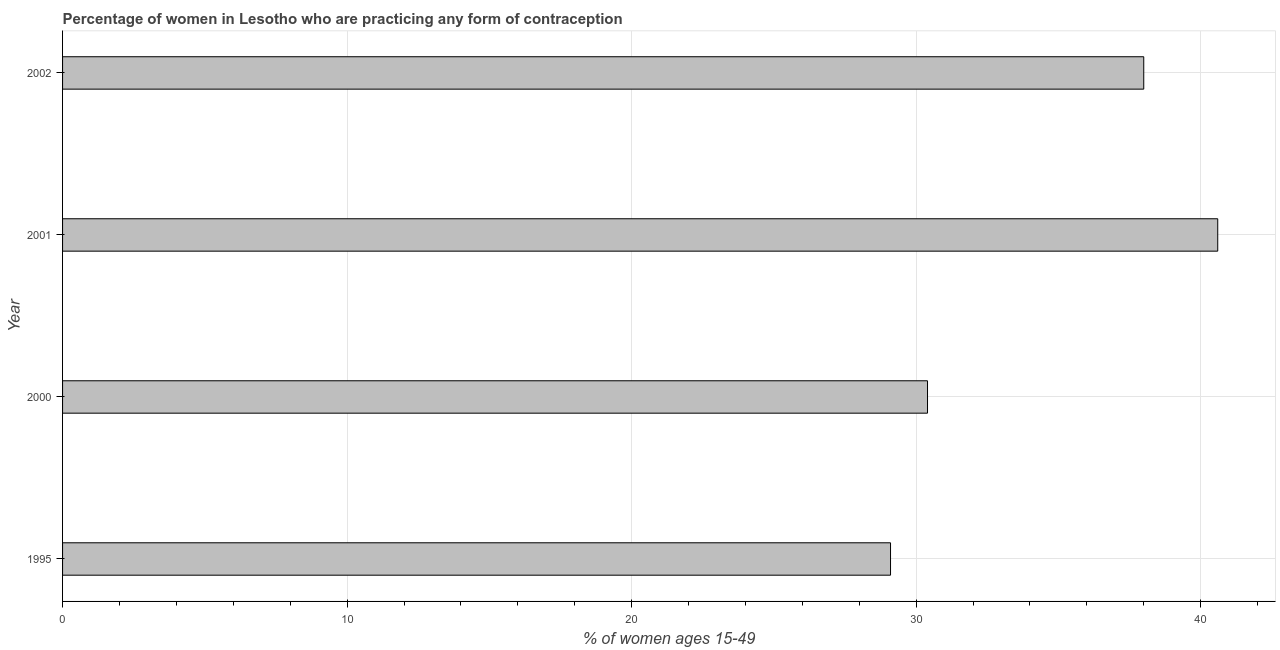Does the graph contain any zero values?
Provide a short and direct response. No. What is the title of the graph?
Provide a succinct answer. Percentage of women in Lesotho who are practicing any form of contraception. What is the label or title of the X-axis?
Offer a very short reply. % of women ages 15-49. What is the label or title of the Y-axis?
Your response must be concise. Year. What is the contraceptive prevalence in 1995?
Your answer should be very brief. 29.1. Across all years, what is the maximum contraceptive prevalence?
Your answer should be very brief. 40.6. Across all years, what is the minimum contraceptive prevalence?
Offer a very short reply. 29.1. In which year was the contraceptive prevalence maximum?
Keep it short and to the point. 2001. In which year was the contraceptive prevalence minimum?
Offer a terse response. 1995. What is the sum of the contraceptive prevalence?
Provide a succinct answer. 138.1. What is the average contraceptive prevalence per year?
Your response must be concise. 34.52. What is the median contraceptive prevalence?
Provide a succinct answer. 34.2. In how many years, is the contraceptive prevalence greater than 2 %?
Your answer should be very brief. 4. Is the difference between the contraceptive prevalence in 2000 and 2002 greater than the difference between any two years?
Provide a succinct answer. No. Is the sum of the contraceptive prevalence in 1995 and 2001 greater than the maximum contraceptive prevalence across all years?
Offer a very short reply. Yes. How many bars are there?
Keep it short and to the point. 4. What is the difference between two consecutive major ticks on the X-axis?
Provide a short and direct response. 10. Are the values on the major ticks of X-axis written in scientific E-notation?
Provide a short and direct response. No. What is the % of women ages 15-49 of 1995?
Make the answer very short. 29.1. What is the % of women ages 15-49 of 2000?
Your answer should be very brief. 30.4. What is the % of women ages 15-49 of 2001?
Provide a short and direct response. 40.6. What is the difference between the % of women ages 15-49 in 1995 and 2000?
Offer a terse response. -1.3. What is the difference between the % of women ages 15-49 in 1995 and 2001?
Provide a succinct answer. -11.5. What is the difference between the % of women ages 15-49 in 1995 and 2002?
Your answer should be compact. -8.9. What is the difference between the % of women ages 15-49 in 2000 and 2001?
Make the answer very short. -10.2. What is the difference between the % of women ages 15-49 in 2000 and 2002?
Provide a succinct answer. -7.6. What is the difference between the % of women ages 15-49 in 2001 and 2002?
Provide a succinct answer. 2.6. What is the ratio of the % of women ages 15-49 in 1995 to that in 2001?
Ensure brevity in your answer.  0.72. What is the ratio of the % of women ages 15-49 in 1995 to that in 2002?
Your answer should be compact. 0.77. What is the ratio of the % of women ages 15-49 in 2000 to that in 2001?
Make the answer very short. 0.75. What is the ratio of the % of women ages 15-49 in 2000 to that in 2002?
Your answer should be compact. 0.8. What is the ratio of the % of women ages 15-49 in 2001 to that in 2002?
Your response must be concise. 1.07. 